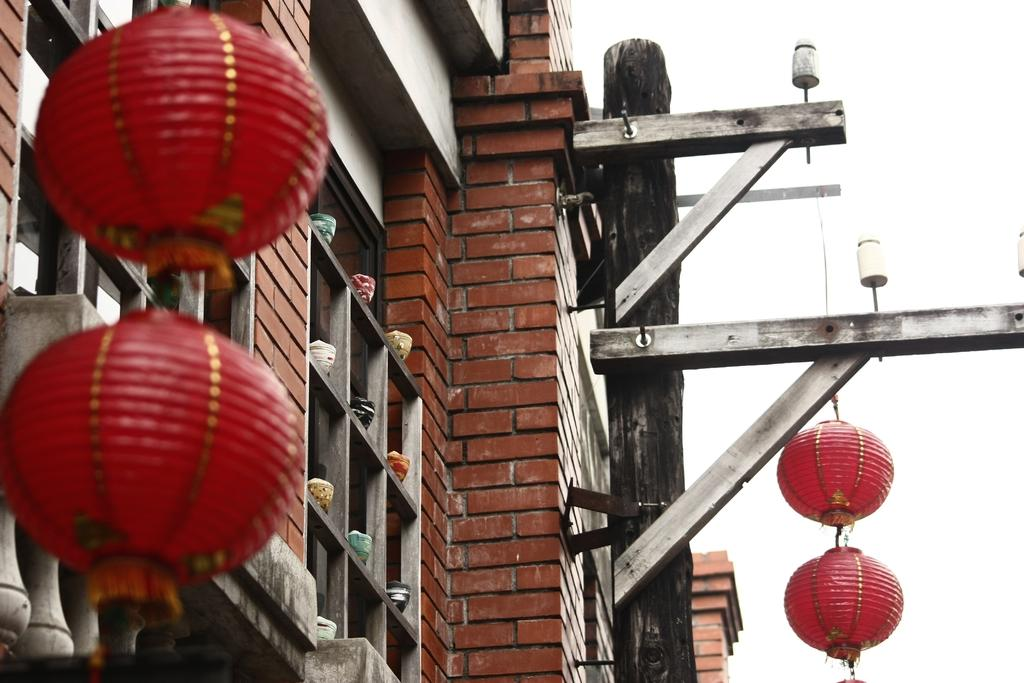What type of decoration is present in the image? There are red colored lanterns in the image. How are the lanterns suspended in the image? The lanterns are attached to threads. What can be seen in the background of the image? There is a building in the background of the image. Can you describe the building's exterior? The building has a brick wall and glass windows. What is visible in the sky in the image? The sky is visible in the background of the image. What type of trousers are hanging from the lanterns in the image? There are no trousers present in the image; it only features red colored lanterns attached to threads. 